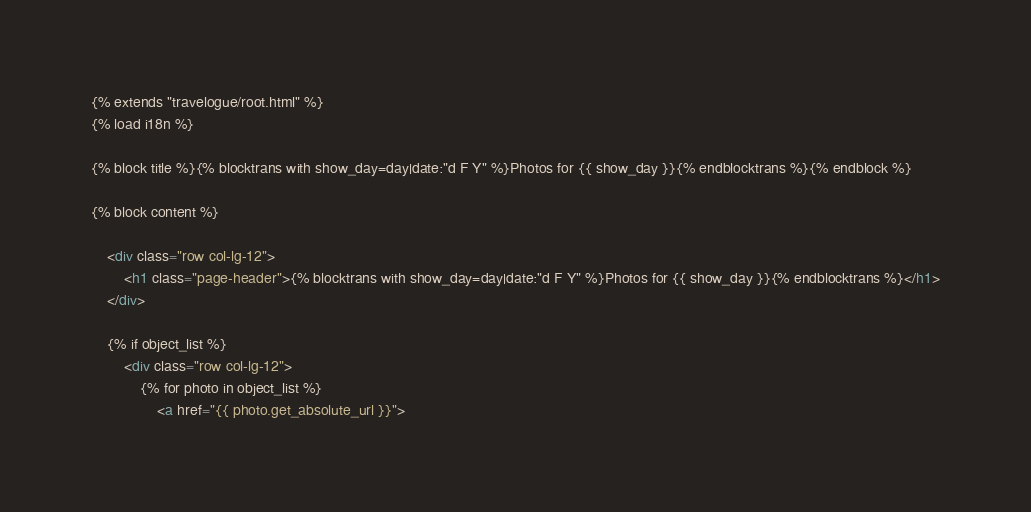Convert code to text. <code><loc_0><loc_0><loc_500><loc_500><_HTML_>{% extends "travelogue/root.html" %}
{% load i18n %}

{% block title %}{% blocktrans with show_day=day|date:"d F Y" %}Photos for {{ show_day }}{% endblocktrans %}{% endblock %}

{% block content %}

    <div class="row col-lg-12">
        <h1 class="page-header">{% blocktrans with show_day=day|date:"d F Y" %}Photos for {{ show_day }}{% endblocktrans %}</h1>
    </div>

	{% if object_list %}
		<div class="row col-lg-12">
		    {% for photo in object_list %}
		        <a href="{{ photo.get_absolute_url }}"></code> 